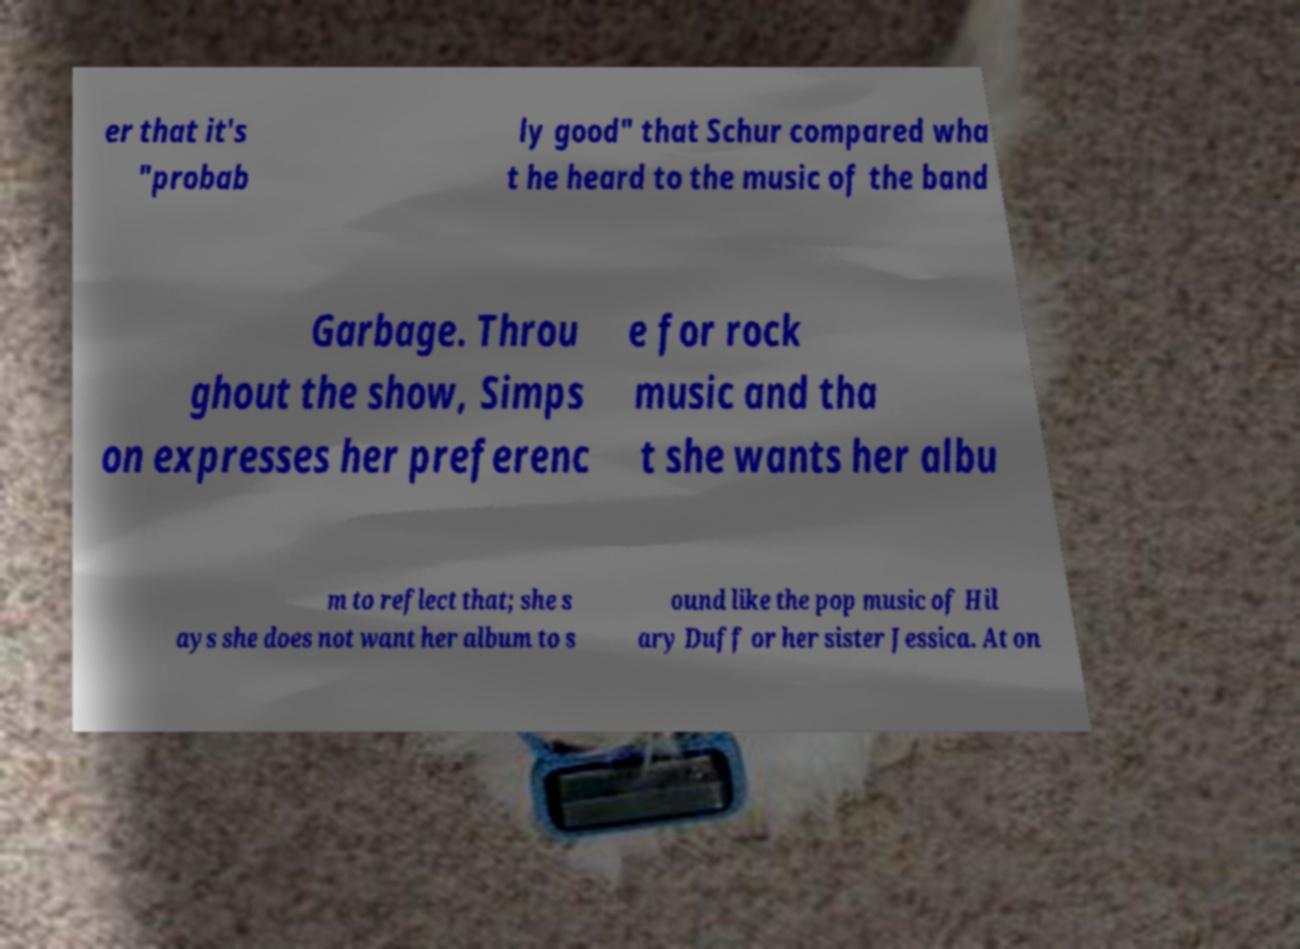Please read and relay the text visible in this image. What does it say? er that it's "probab ly good" that Schur compared wha t he heard to the music of the band Garbage. Throu ghout the show, Simps on expresses her preferenc e for rock music and tha t she wants her albu m to reflect that; she s ays she does not want her album to s ound like the pop music of Hil ary Duff or her sister Jessica. At on 